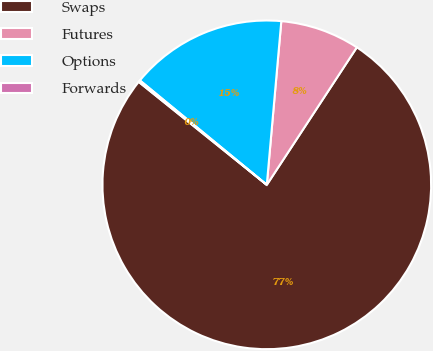<chart> <loc_0><loc_0><loc_500><loc_500><pie_chart><fcel>Swaps<fcel>Futures<fcel>Options<fcel>Forwards<nl><fcel>76.54%<fcel>7.82%<fcel>15.45%<fcel>0.18%<nl></chart> 